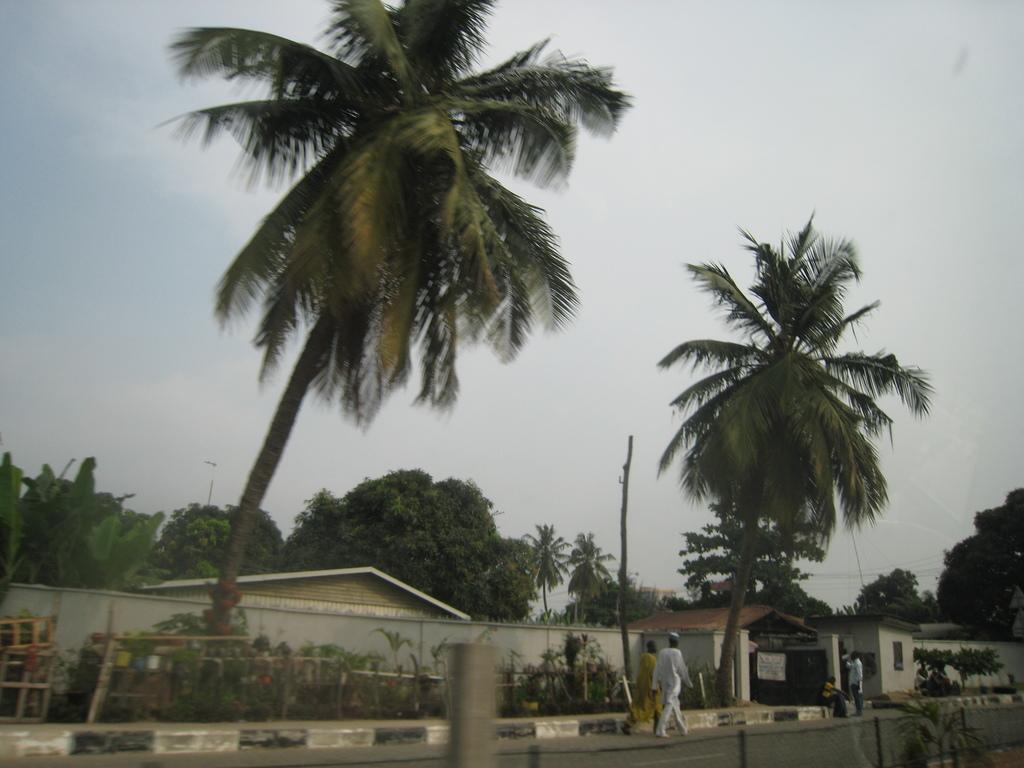What are the two persons in the image doing? The two persons in the image are walking. What type of natural elements can be seen in the image? There are trees and plants in the image. What is the color of the plants and trees in the image? The plants and trees are green in color. What is visible in the background of the image? The sky is visible in the image. What is the color of the sky in the image? The sky is white in color. What type of structure is present in the image? There is a house in the image. What type of government is depicted in the image? There is no depiction of a government in the image; it features two persons walking, trees, plants, a house, and a white sky. Can you see a boy holding a rifle in the image? There is no boy or rifle present in the image. 